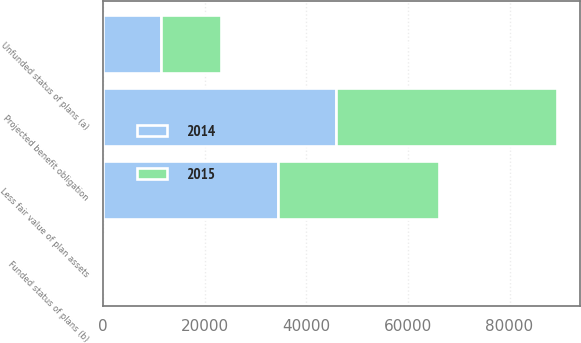<chart> <loc_0><loc_0><loc_500><loc_500><stacked_bar_chart><ecel><fcel>Projected benefit obligation<fcel>Less fair value of plan assets<fcel>Unfunded status of plans (a)<fcel>Funded status of plans (b)<nl><fcel>2015<fcel>43575<fcel>31768<fcel>11807<fcel>201<nl><fcel>2014<fcel>45741<fcel>34328<fcel>11413<fcel>204<nl></chart> 